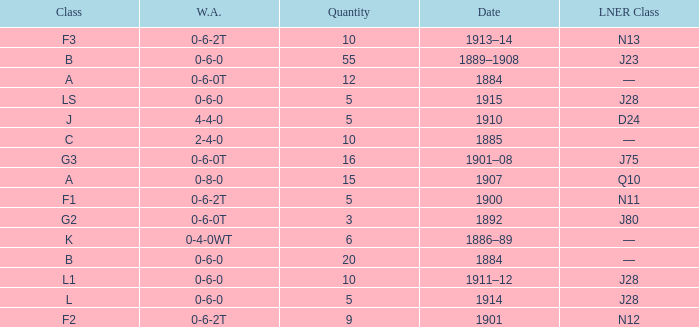What class is associated with a W.A. of 0-8-0? A. 